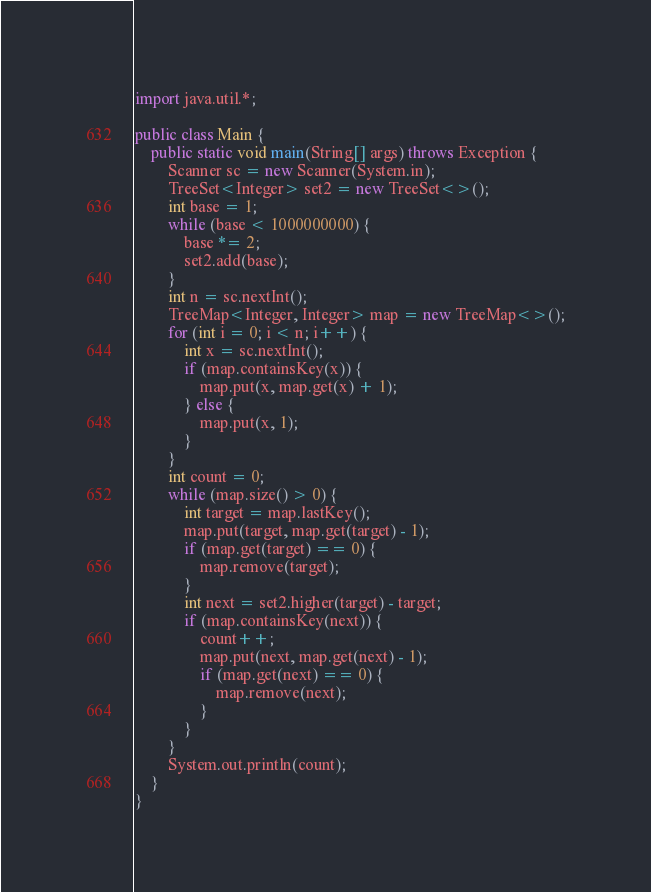Convert code to text. <code><loc_0><loc_0><loc_500><loc_500><_Java_>import java.util.*;

public class Main {
    public static void main(String[] args) throws Exception {
        Scanner sc = new Scanner(System.in);
        TreeSet<Integer> set2 = new TreeSet<>();
        int base = 1;
        while (base < 1000000000) {
            base *= 2;
            set2.add(base);
        }
        int n = sc.nextInt();
        TreeMap<Integer, Integer> map = new TreeMap<>();
        for (int i = 0; i < n; i++) {
            int x = sc.nextInt();
            if (map.containsKey(x)) {
                map.put(x, map.get(x) + 1);
            } else {
                map.put(x, 1);
            }
        }
        int count = 0;
        while (map.size() > 0) {
            int target = map.lastKey();
            map.put(target, map.get(target) - 1);
            if (map.get(target) == 0) {
                map.remove(target);
            }
            int next = set2.higher(target) - target;
            if (map.containsKey(next)) {
                count++;
                map.put(next, map.get(next) - 1);
                if (map.get(next) == 0) {
                    map.remove(next);
                }
            }
        }
        System.out.println(count);
    }
}
</code> 